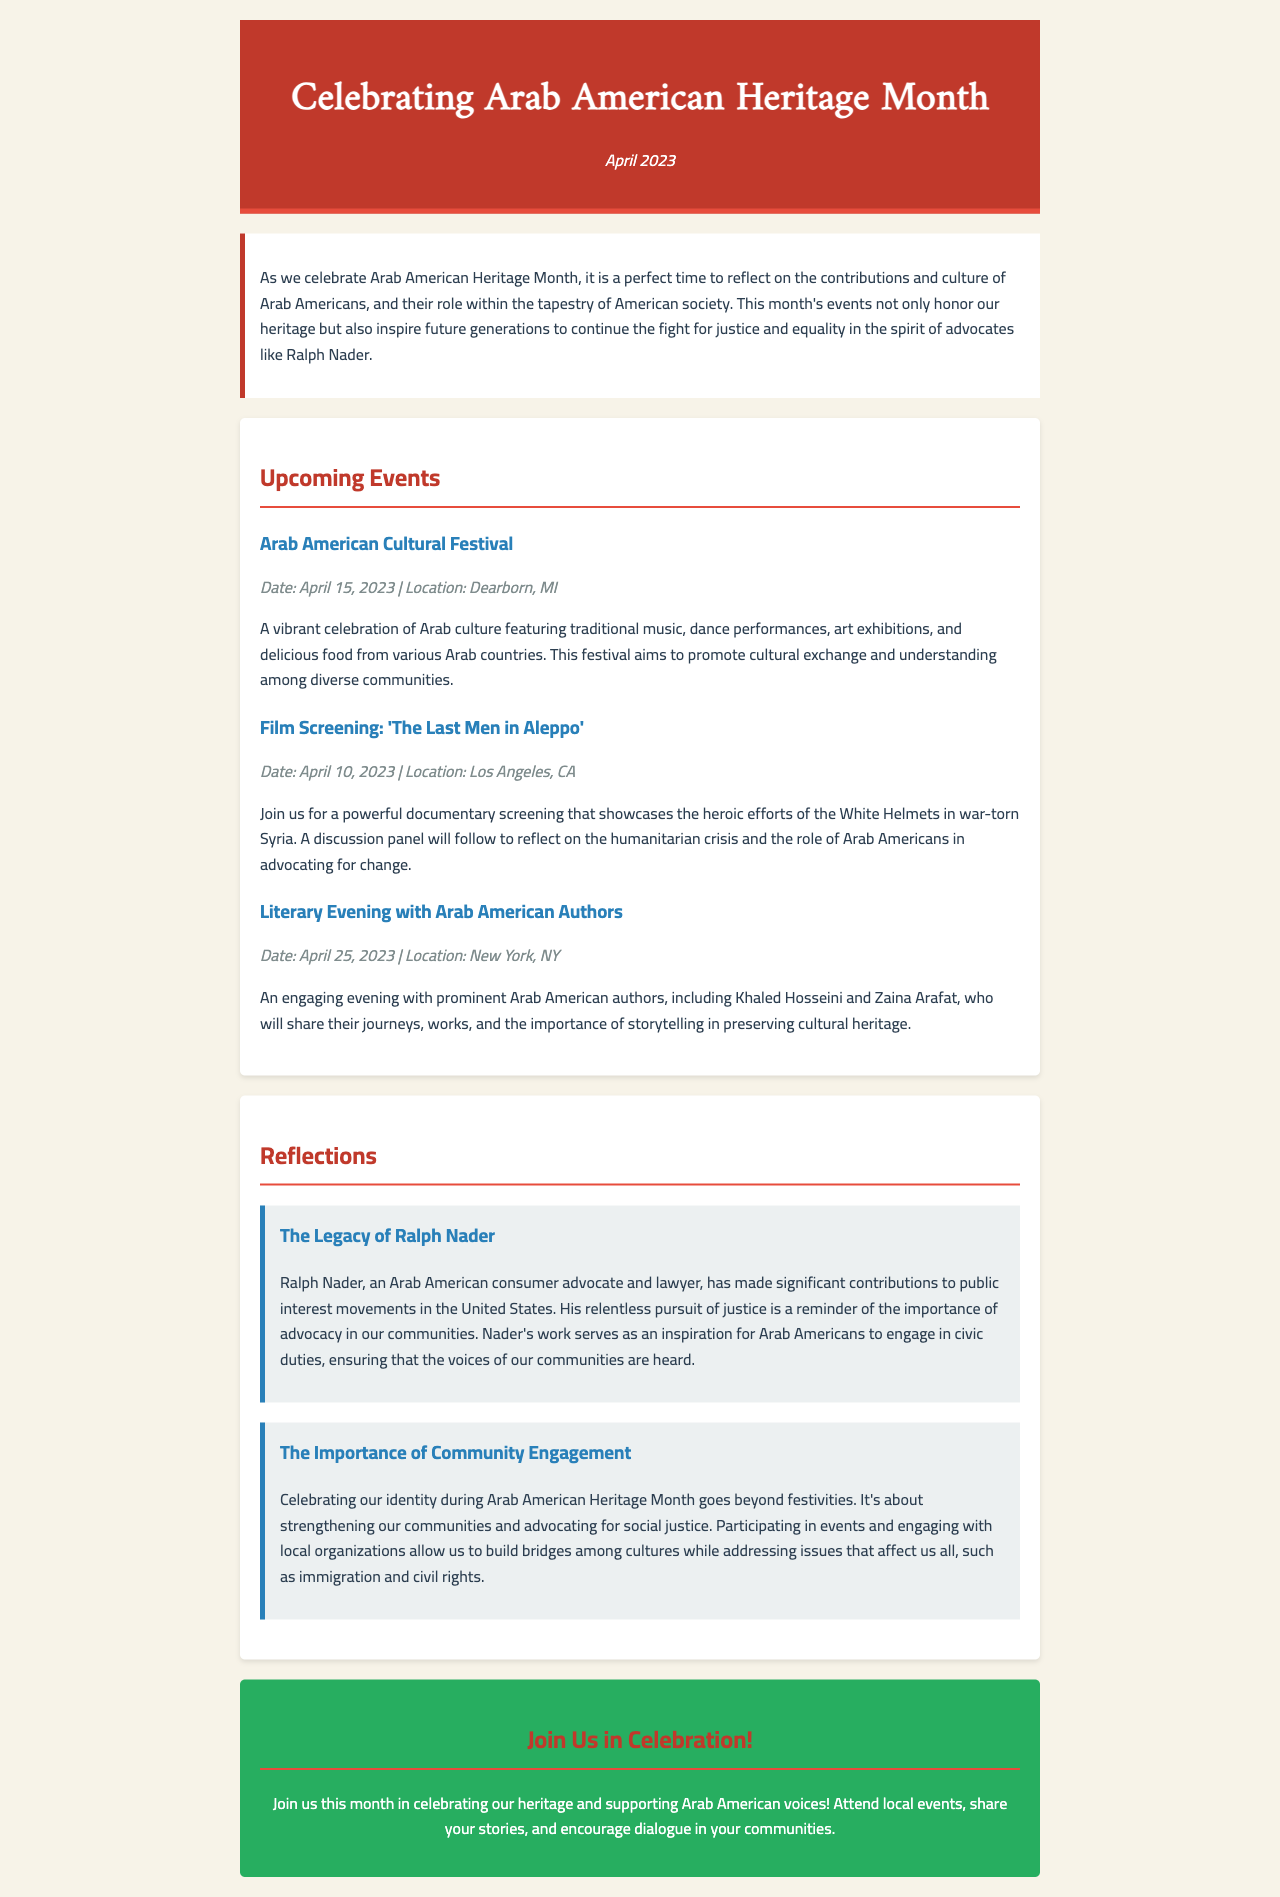What month is being celebrated? The document highlights the celebration of Arab American Heritage Month, specifically in April.
Answer: April What is the location of the Arab American Cultural Festival? The document states that the festival is located in Dearborn, MI.
Answer: Dearborn, MI Who is one of the authors featured in the Literary Evening? The document mentions Khaled Hosseini as one of the prominent Arab American authors.
Answer: Khaled Hosseini When is the film screening of 'The Last Men in Aleppo'? The document provides a specific date for the screening, which is April 10, 2023.
Answer: April 10, 2023 What significant contribution is Ralph Nader known for? The document describes Ralph Nader as a consumer advocate and lawyer who contributed to public interest movements.
Answer: Consumer advocate How does the document suggest celebrating Arab American Heritage Month? It encourages attending local events, sharing stories, and supporting Arab American voices.
Answer: Attend local events What are two key themes in the reflections section? The themes include the legacy of Ralph Nader and the importance of community engagement.
Answer: Legacy of Ralph Nader, community engagement What type of events are highlighted in the document? The document highlights cultural, film, and literary events as part of the heritage celebration.
Answer: Cultural, film, literary events What role does the newsletter suggest for Arab Americans regarding advocacy? It emphasizes the importance of advocacy in ensuring community voices are heard.
Answer: Advocacy 